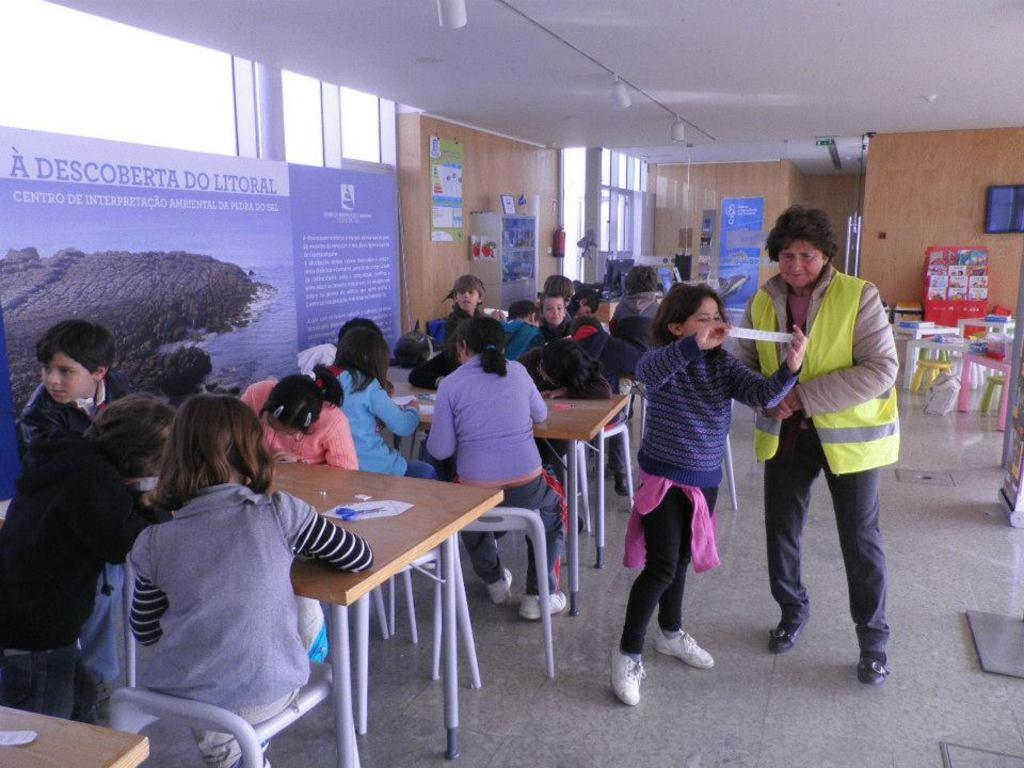How many people are in the group in the image? The number of people in the group cannot be determined from the provided facts. What are some of the people in the group doing? Some persons are sitting on chairs, and some are standing. What objects can be seen in the image? There are objects visible in the image, but their specific nature cannot be determined from the provided facts. What type of structure is present in the image? There is a board, a wall, and a roof in the image, suggesting a room or enclosed space. What type of cover is present on the roof in the image? There is no information about a cover on the roof in the provided facts. What type of space is depicted in the image? The image depicts a room or enclosed space, as indicated by the presence of a board, a wall, and a roof. What type of destruction is visible in the image? There is no indication of destruction in the provided facts. 